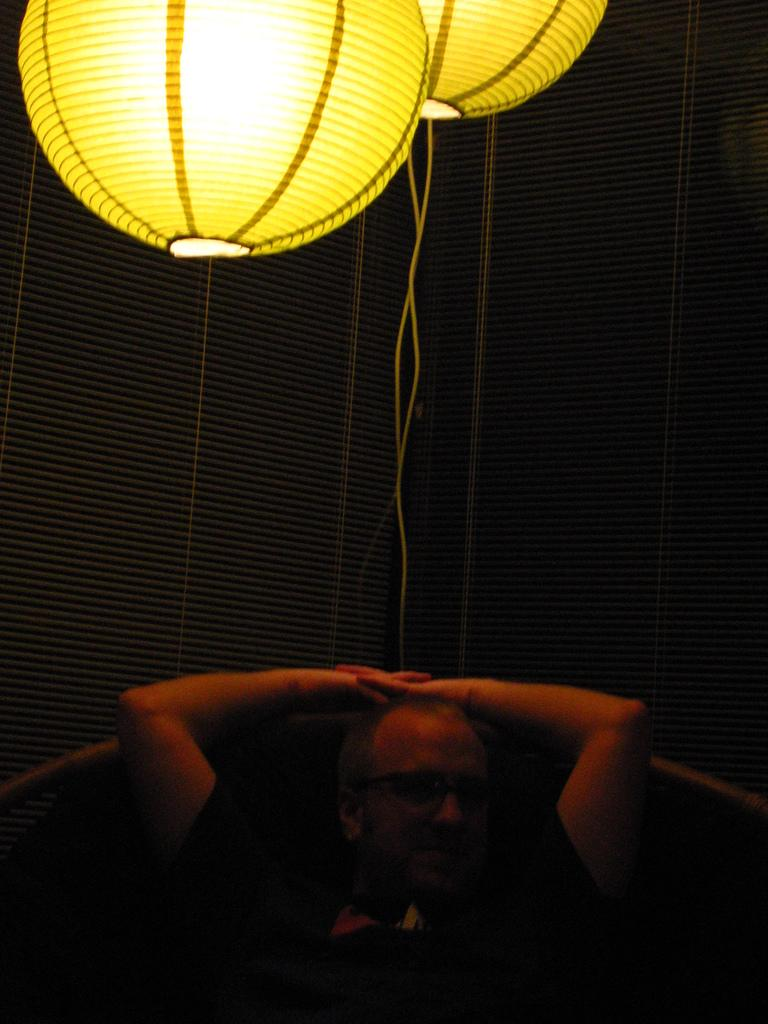What is the man in the image doing? The man is sitting on a chair in the image. What objects can be seen hanging in the image? There are two lanterns in the image. What color are the lanterns? The lanterns are yellow in color. What is the background of the image made up of? There is a wall in the image. What type of haircut does the man have in the image? There is no information about the man's haircut in the image. What is the reason for the man sitting on the chair in the image? The image does not provide any information about the reason for the man sitting on the chair. 